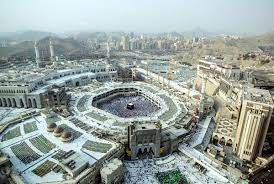What do you think is going on in this snapshot? The image captures an aerial view of the Great Mosque of Mecca, the holiest site in Islam, showcasing its vast, sprawling white architecture. At the center, the Kaaba, a cube-shaped building draped in black, draws immediate attention. This structure is the qibla, the direction that Muslims worldwide face during prayers. The mosque's multiple minarets and domes elegantly pierce the sky, symbolizing a bridge between the earth and the divine. Surrounding the mosque, modern high-rise buildings contrast sharply with the ancient, sacred site, indicating the blend of old and new in this spiritual hub. The distant mountains serve as a majestic backdrop, symbolizing endurance and permanence. This image not only showcases architectural grandeur but also encapsulates the cultural and spiritual heartbeat of the Islamic world. 